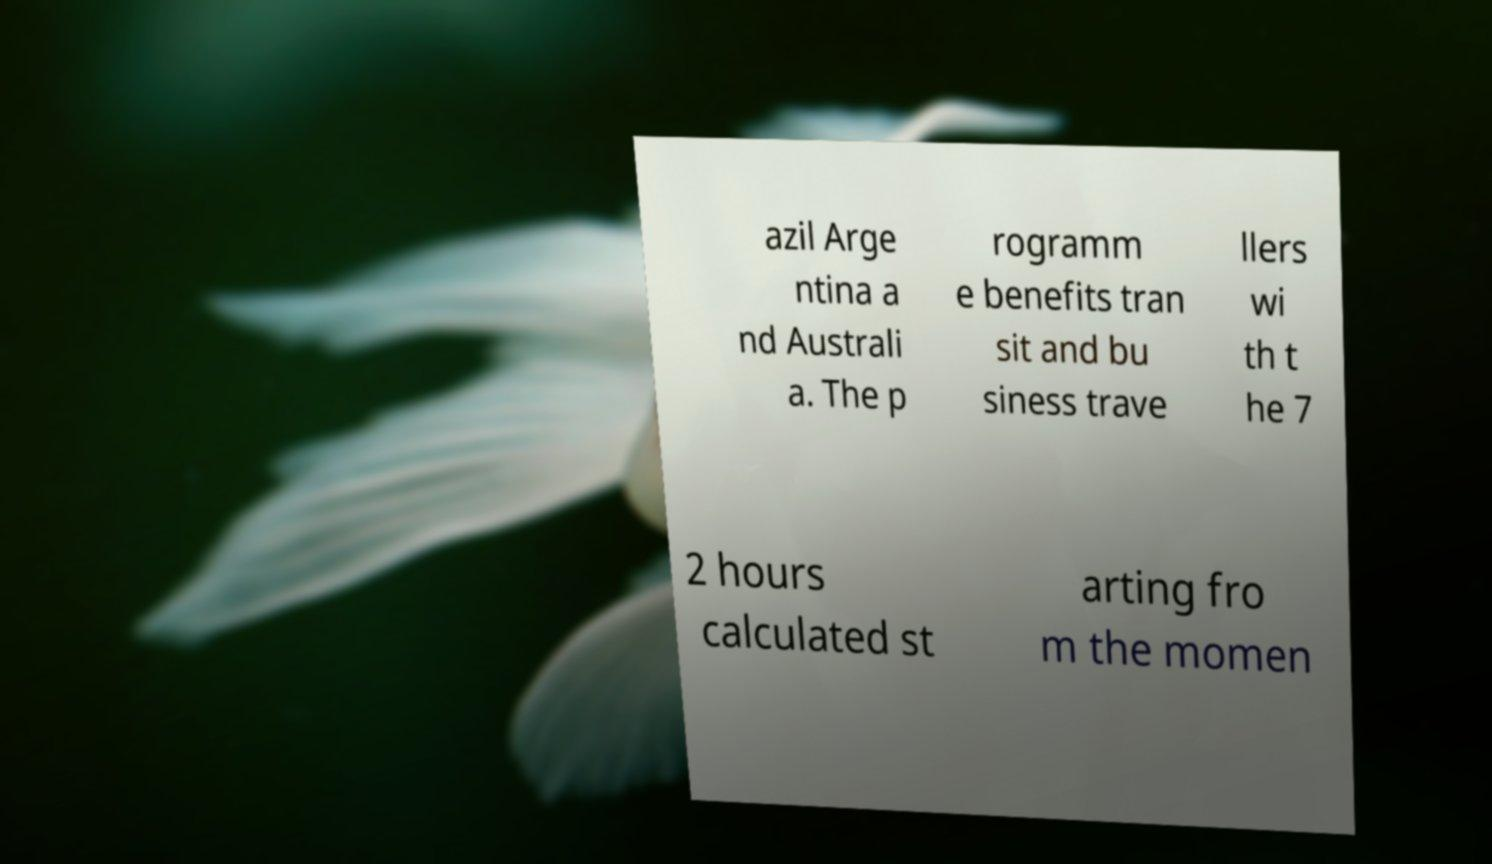Could you assist in decoding the text presented in this image and type it out clearly? azil Arge ntina a nd Australi a. The p rogramm e benefits tran sit and bu siness trave llers wi th t he 7 2 hours calculated st arting fro m the momen 